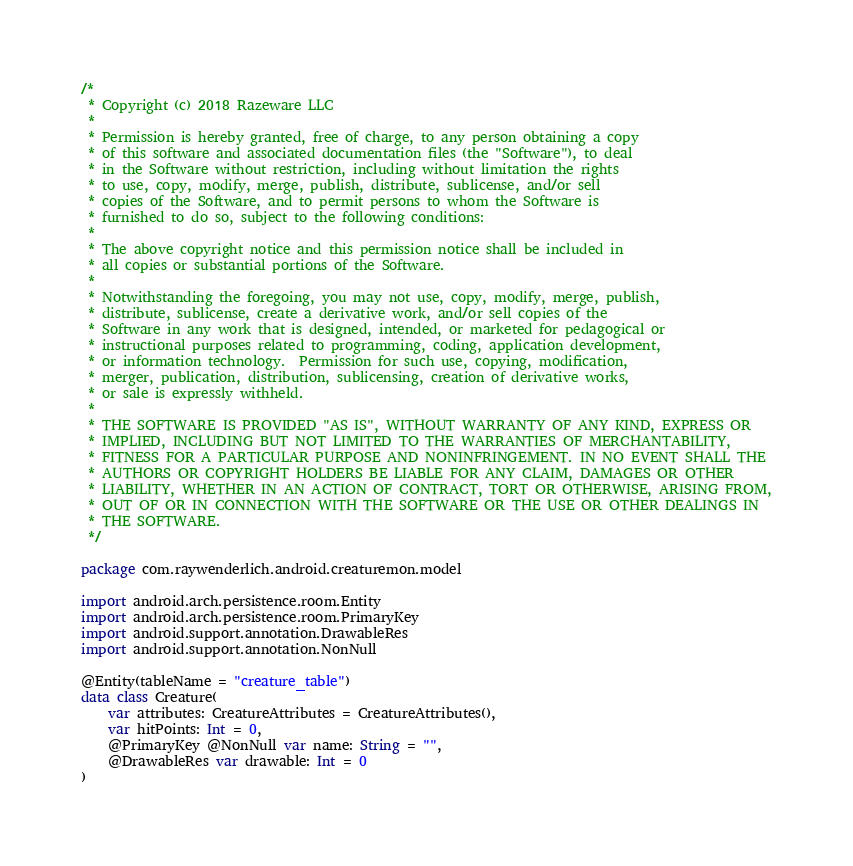<code> <loc_0><loc_0><loc_500><loc_500><_Kotlin_>/*
 * Copyright (c) 2018 Razeware LLC
 *
 * Permission is hereby granted, free of charge, to any person obtaining a copy
 * of this software and associated documentation files (the "Software"), to deal
 * in the Software without restriction, including without limitation the rights
 * to use, copy, modify, merge, publish, distribute, sublicense, and/or sell
 * copies of the Software, and to permit persons to whom the Software is
 * furnished to do so, subject to the following conditions:
 *
 * The above copyright notice and this permission notice shall be included in
 * all copies or substantial portions of the Software.
 *
 * Notwithstanding the foregoing, you may not use, copy, modify, merge, publish,
 * distribute, sublicense, create a derivative work, and/or sell copies of the
 * Software in any work that is designed, intended, or marketed for pedagogical or
 * instructional purposes related to programming, coding, application development,
 * or information technology.  Permission for such use, copying, modification,
 * merger, publication, distribution, sublicensing, creation of derivative works,
 * or sale is expressly withheld.
 *
 * THE SOFTWARE IS PROVIDED "AS IS", WITHOUT WARRANTY OF ANY KIND, EXPRESS OR
 * IMPLIED, INCLUDING BUT NOT LIMITED TO THE WARRANTIES OF MERCHANTABILITY,
 * FITNESS FOR A PARTICULAR PURPOSE AND NONINFRINGEMENT. IN NO EVENT SHALL THE
 * AUTHORS OR COPYRIGHT HOLDERS BE LIABLE FOR ANY CLAIM, DAMAGES OR OTHER
 * LIABILITY, WHETHER IN AN ACTION OF CONTRACT, TORT OR OTHERWISE, ARISING FROM,
 * OUT OF OR IN CONNECTION WITH THE SOFTWARE OR THE USE OR OTHER DEALINGS IN
 * THE SOFTWARE.
 */

package com.raywenderlich.android.creaturemon.model

import android.arch.persistence.room.Entity
import android.arch.persistence.room.PrimaryKey
import android.support.annotation.DrawableRes
import android.support.annotation.NonNull

@Entity(tableName = "creature_table")
data class Creature(
    var attributes: CreatureAttributes = CreatureAttributes(),
    var hitPoints: Int = 0,
    @PrimaryKey @NonNull var name: String = "",
    @DrawableRes var drawable: Int = 0
)</code> 